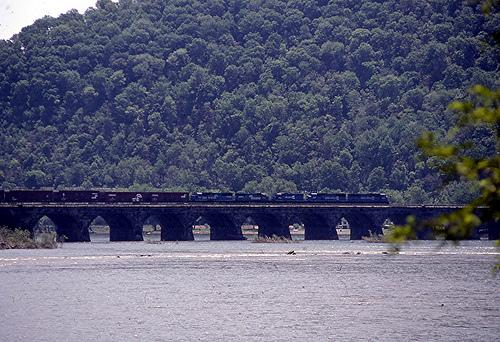Speak about the relationship between the train and the bridge in the image. The train is moving on the tracks that are placed on the bridge. What is the dominant mode of transportation in the image? The train is the dominant mode of transportation. Count the number of train cars visible on the tracks. There are 9 train cars visible on the tracks. Is the train attached to cargo cars, and if so, what color are they? Yes, the train is attached to reddish-brown cargo cars. Please provide a short description of the environment surrounding the object in focus. The image shows a stone or brick bridge over gray water, surrounded by lush green trees and a sandy shoreline. Please describe the condition of the vegetation in the image. The vegetation is lush, including green trees in the background, green leaves on branches, and small bushes on the left side of the bridge. Enumerate the different elements present in the image. Train, train cars, tracks, bridge, arches, water, trees, grass, bushes, and shoreline. What is the emotion or mood that the image evokes? The image may evoke a sense of peacefulness and tranquility as the train passes through a beautiful, lush environment. What type of bridge is depicted in the image? The bridge is a dark gray stone or brick bridge with multiple arches. Identify the primary color of the train cars and any additional colors on them. The train cars are primarily blue with white letters and red cargo cars. 